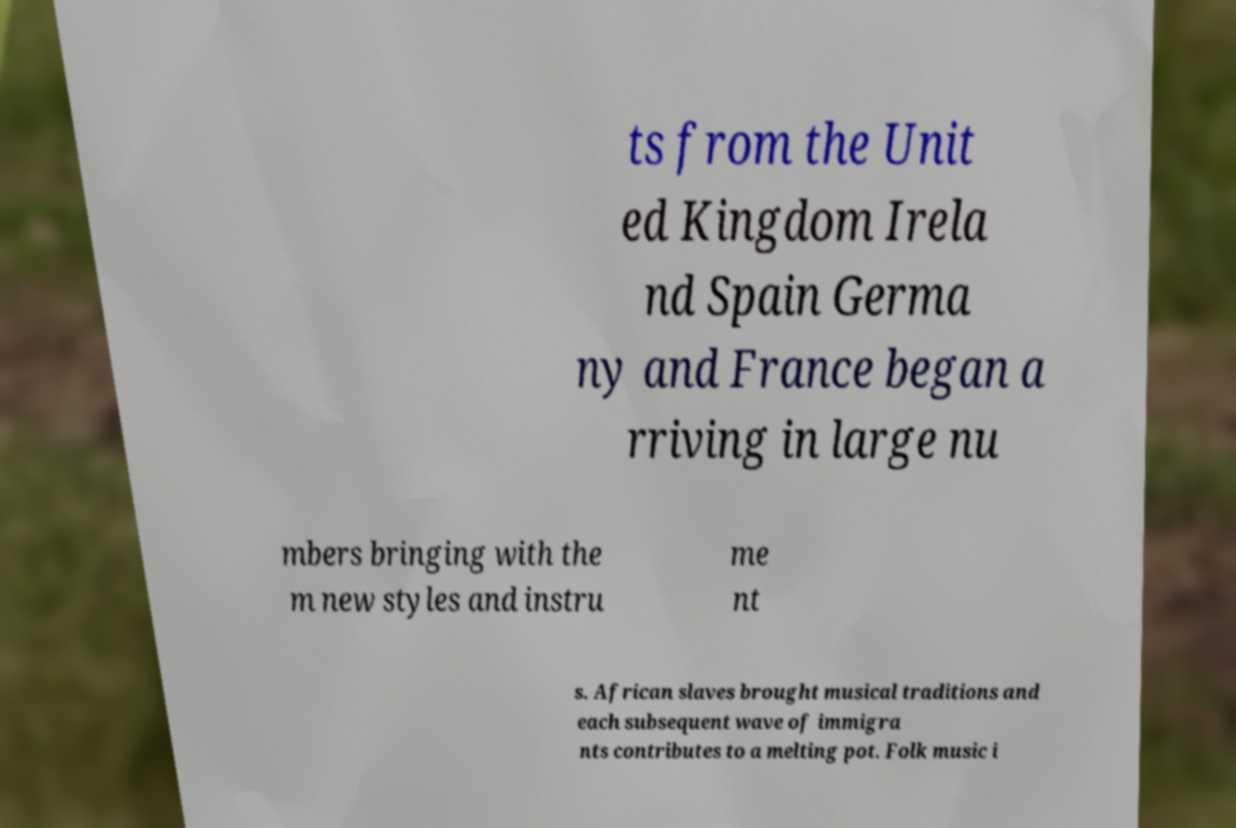Could you extract and type out the text from this image? ts from the Unit ed Kingdom Irela nd Spain Germa ny and France began a rriving in large nu mbers bringing with the m new styles and instru me nt s. African slaves brought musical traditions and each subsequent wave of immigra nts contributes to a melting pot. Folk music i 